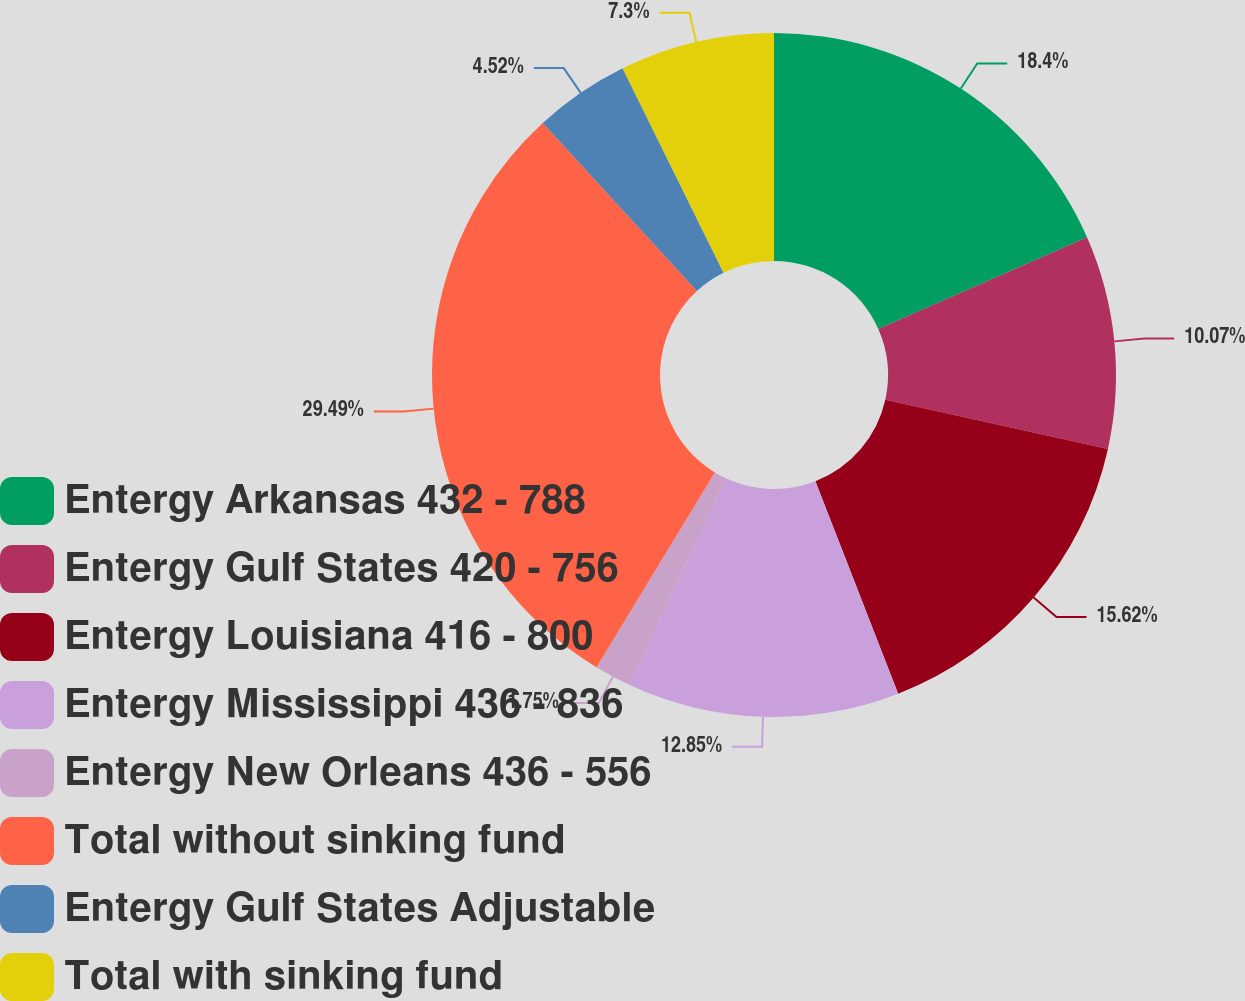Convert chart. <chart><loc_0><loc_0><loc_500><loc_500><pie_chart><fcel>Entergy Arkansas 432 - 788<fcel>Entergy Gulf States 420 - 756<fcel>Entergy Louisiana 416 - 800<fcel>Entergy Mississippi 436 - 836<fcel>Entergy New Orleans 436 - 556<fcel>Total without sinking fund<fcel>Entergy Gulf States Adjustable<fcel>Total with sinking fund<nl><fcel>18.4%<fcel>10.07%<fcel>15.62%<fcel>12.85%<fcel>1.75%<fcel>29.5%<fcel>4.52%<fcel>7.3%<nl></chart> 